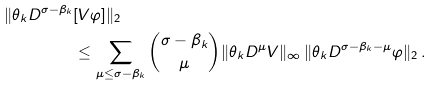<formula> <loc_0><loc_0><loc_500><loc_500>\| \theta _ { k } D ^ { \sigma - \beta _ { k } } & [ V \varphi ] \| _ { 2 } \\ & \leq \sum _ { \mu \leq \sigma - \beta _ { k } } \binom { \sigma - \beta _ { k } } { \mu } \| \theta _ { k } D ^ { \mu } V \| _ { \infty } \, \| \theta _ { k } D ^ { \sigma - \beta _ { k } - \mu } \varphi \| _ { 2 } \, .</formula> 